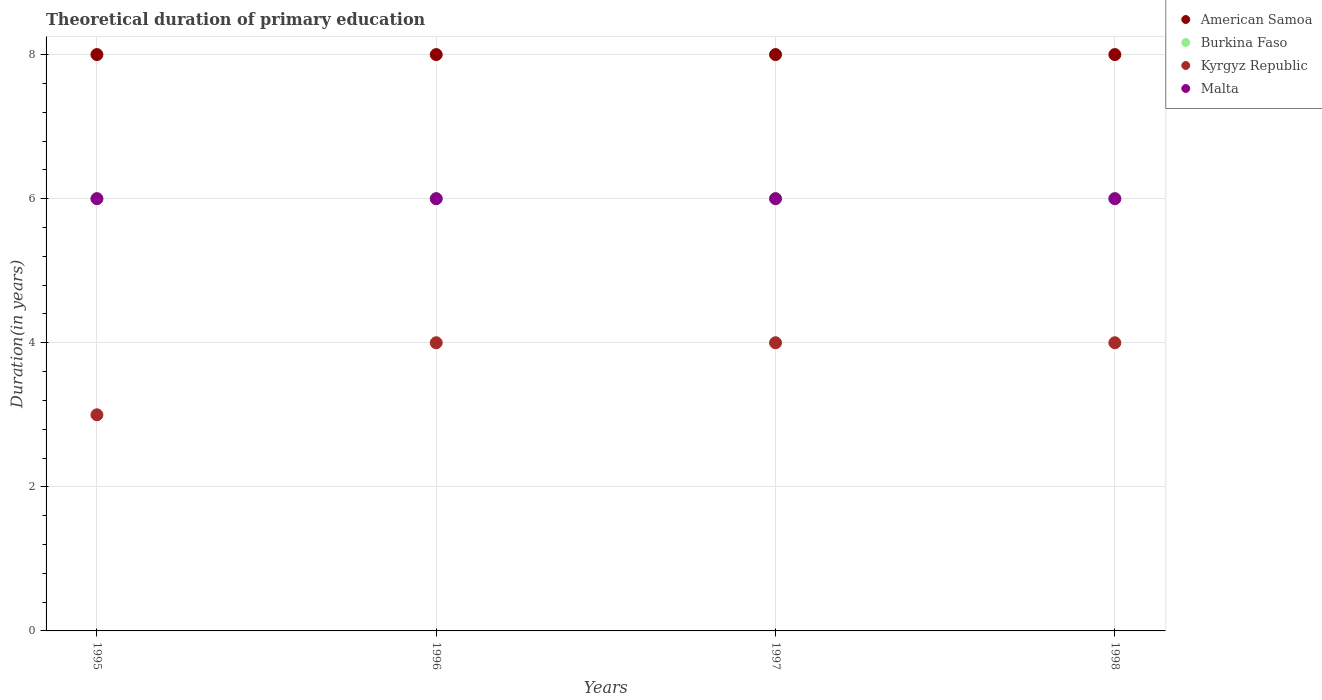How many different coloured dotlines are there?
Provide a succinct answer. 4. What is the total theoretical duration of primary education in Burkina Faso in 1998?
Your response must be concise. 6. Across all years, what is the maximum total theoretical duration of primary education in Kyrgyz Republic?
Your answer should be very brief. 4. Across all years, what is the minimum total theoretical duration of primary education in Kyrgyz Republic?
Your response must be concise. 3. In which year was the total theoretical duration of primary education in Malta maximum?
Keep it short and to the point. 1995. What is the total total theoretical duration of primary education in Burkina Faso in the graph?
Your answer should be very brief. 24. In how many years, is the total theoretical duration of primary education in Malta greater than 5.2 years?
Provide a short and direct response. 4. What is the ratio of the total theoretical duration of primary education in Kyrgyz Republic in 1996 to that in 1998?
Provide a succinct answer. 1. What is the difference between the highest and the lowest total theoretical duration of primary education in Kyrgyz Republic?
Your answer should be compact. 1. In how many years, is the total theoretical duration of primary education in American Samoa greater than the average total theoretical duration of primary education in American Samoa taken over all years?
Keep it short and to the point. 0. Does the total theoretical duration of primary education in American Samoa monotonically increase over the years?
Offer a terse response. No. How many years are there in the graph?
Your answer should be very brief. 4. Does the graph contain any zero values?
Keep it short and to the point. No. Does the graph contain grids?
Your response must be concise. Yes. Where does the legend appear in the graph?
Ensure brevity in your answer.  Top right. How many legend labels are there?
Your answer should be very brief. 4. What is the title of the graph?
Make the answer very short. Theoretical duration of primary education. Does "Somalia" appear as one of the legend labels in the graph?
Ensure brevity in your answer.  No. What is the label or title of the X-axis?
Ensure brevity in your answer.  Years. What is the label or title of the Y-axis?
Your answer should be compact. Duration(in years). What is the Duration(in years) in Kyrgyz Republic in 1995?
Give a very brief answer. 3. What is the Duration(in years) of American Samoa in 1996?
Provide a succinct answer. 8. What is the Duration(in years) of Burkina Faso in 1996?
Offer a terse response. 6. What is the Duration(in years) of Kyrgyz Republic in 1996?
Provide a short and direct response. 4. What is the Duration(in years) of American Samoa in 1997?
Offer a very short reply. 8. What is the Duration(in years) in Malta in 1997?
Offer a very short reply. 6. What is the Duration(in years) of Burkina Faso in 1998?
Offer a terse response. 6. What is the Duration(in years) of Kyrgyz Republic in 1998?
Provide a succinct answer. 4. Across all years, what is the maximum Duration(in years) in American Samoa?
Ensure brevity in your answer.  8. Across all years, what is the maximum Duration(in years) in Burkina Faso?
Make the answer very short. 6. Across all years, what is the maximum Duration(in years) in Kyrgyz Republic?
Offer a terse response. 4. What is the total Duration(in years) in American Samoa in the graph?
Ensure brevity in your answer.  32. What is the total Duration(in years) of Kyrgyz Republic in the graph?
Make the answer very short. 15. What is the difference between the Duration(in years) of Kyrgyz Republic in 1995 and that in 1996?
Give a very brief answer. -1. What is the difference between the Duration(in years) in Malta in 1995 and that in 1996?
Provide a succinct answer. 0. What is the difference between the Duration(in years) in Malta in 1995 and that in 1997?
Your answer should be very brief. 0. What is the difference between the Duration(in years) in American Samoa in 1995 and that in 1998?
Provide a short and direct response. 0. What is the difference between the Duration(in years) of Burkina Faso in 1995 and that in 1998?
Provide a succinct answer. 0. What is the difference between the Duration(in years) in Kyrgyz Republic in 1995 and that in 1998?
Your response must be concise. -1. What is the difference between the Duration(in years) in Malta in 1995 and that in 1998?
Offer a terse response. 0. What is the difference between the Duration(in years) of American Samoa in 1996 and that in 1997?
Ensure brevity in your answer.  0. What is the difference between the Duration(in years) of American Samoa in 1996 and that in 1998?
Keep it short and to the point. 0. What is the difference between the Duration(in years) in Burkina Faso in 1996 and that in 1998?
Give a very brief answer. 0. What is the difference between the Duration(in years) of Kyrgyz Republic in 1996 and that in 1998?
Keep it short and to the point. 0. What is the difference between the Duration(in years) in American Samoa in 1997 and that in 1998?
Offer a terse response. 0. What is the difference between the Duration(in years) in Burkina Faso in 1997 and that in 1998?
Provide a succinct answer. 0. What is the difference between the Duration(in years) in Burkina Faso in 1995 and the Duration(in years) in Kyrgyz Republic in 1996?
Offer a terse response. 2. What is the difference between the Duration(in years) in Kyrgyz Republic in 1995 and the Duration(in years) in Malta in 1996?
Your answer should be very brief. -3. What is the difference between the Duration(in years) of American Samoa in 1995 and the Duration(in years) of Kyrgyz Republic in 1997?
Provide a succinct answer. 4. What is the difference between the Duration(in years) of American Samoa in 1995 and the Duration(in years) of Malta in 1997?
Keep it short and to the point. 2. What is the difference between the Duration(in years) of American Samoa in 1995 and the Duration(in years) of Burkina Faso in 1998?
Offer a terse response. 2. What is the difference between the Duration(in years) in American Samoa in 1995 and the Duration(in years) in Kyrgyz Republic in 1998?
Your answer should be very brief. 4. What is the difference between the Duration(in years) of Burkina Faso in 1995 and the Duration(in years) of Malta in 1998?
Your answer should be compact. 0. What is the difference between the Duration(in years) of Kyrgyz Republic in 1995 and the Duration(in years) of Malta in 1998?
Make the answer very short. -3. What is the difference between the Duration(in years) of Burkina Faso in 1996 and the Duration(in years) of Kyrgyz Republic in 1998?
Your answer should be compact. 2. What is the difference between the Duration(in years) in American Samoa in 1997 and the Duration(in years) in Burkina Faso in 1998?
Give a very brief answer. 2. What is the difference between the Duration(in years) in American Samoa in 1997 and the Duration(in years) in Malta in 1998?
Your answer should be very brief. 2. What is the difference between the Duration(in years) in Burkina Faso in 1997 and the Duration(in years) in Malta in 1998?
Ensure brevity in your answer.  0. What is the difference between the Duration(in years) of Kyrgyz Republic in 1997 and the Duration(in years) of Malta in 1998?
Give a very brief answer. -2. What is the average Duration(in years) in Burkina Faso per year?
Offer a very short reply. 6. What is the average Duration(in years) of Kyrgyz Republic per year?
Make the answer very short. 3.75. In the year 1995, what is the difference between the Duration(in years) in American Samoa and Duration(in years) in Burkina Faso?
Offer a very short reply. 2. In the year 1995, what is the difference between the Duration(in years) of American Samoa and Duration(in years) of Kyrgyz Republic?
Your answer should be very brief. 5. In the year 1995, what is the difference between the Duration(in years) in American Samoa and Duration(in years) in Malta?
Your answer should be very brief. 2. In the year 1995, what is the difference between the Duration(in years) in Burkina Faso and Duration(in years) in Kyrgyz Republic?
Give a very brief answer. 3. In the year 1996, what is the difference between the Duration(in years) in American Samoa and Duration(in years) in Kyrgyz Republic?
Your answer should be compact. 4. In the year 1996, what is the difference between the Duration(in years) of American Samoa and Duration(in years) of Malta?
Offer a terse response. 2. In the year 1996, what is the difference between the Duration(in years) in Burkina Faso and Duration(in years) in Kyrgyz Republic?
Your answer should be compact. 2. In the year 1997, what is the difference between the Duration(in years) in American Samoa and Duration(in years) in Burkina Faso?
Provide a succinct answer. 2. In the year 1997, what is the difference between the Duration(in years) of American Samoa and Duration(in years) of Malta?
Give a very brief answer. 2. In the year 1997, what is the difference between the Duration(in years) in Burkina Faso and Duration(in years) in Kyrgyz Republic?
Offer a very short reply. 2. In the year 1997, what is the difference between the Duration(in years) of Kyrgyz Republic and Duration(in years) of Malta?
Offer a very short reply. -2. In the year 1998, what is the difference between the Duration(in years) of American Samoa and Duration(in years) of Burkina Faso?
Make the answer very short. 2. In the year 1998, what is the difference between the Duration(in years) in American Samoa and Duration(in years) in Malta?
Make the answer very short. 2. In the year 1998, what is the difference between the Duration(in years) of Kyrgyz Republic and Duration(in years) of Malta?
Make the answer very short. -2. What is the ratio of the Duration(in years) of Kyrgyz Republic in 1995 to that in 1996?
Offer a terse response. 0.75. What is the ratio of the Duration(in years) of Malta in 1995 to that in 1996?
Offer a very short reply. 1. What is the ratio of the Duration(in years) of Burkina Faso in 1995 to that in 1997?
Give a very brief answer. 1. What is the ratio of the Duration(in years) of Kyrgyz Republic in 1995 to that in 1997?
Your response must be concise. 0.75. What is the ratio of the Duration(in years) of Malta in 1995 to that in 1997?
Make the answer very short. 1. What is the ratio of the Duration(in years) in Kyrgyz Republic in 1995 to that in 1998?
Make the answer very short. 0.75. What is the ratio of the Duration(in years) in Burkina Faso in 1996 to that in 1997?
Your answer should be very brief. 1. What is the ratio of the Duration(in years) in American Samoa in 1996 to that in 1998?
Offer a very short reply. 1. What is the ratio of the Duration(in years) of Burkina Faso in 1996 to that in 1998?
Make the answer very short. 1. What is the ratio of the Duration(in years) in Malta in 1996 to that in 1998?
Your answer should be compact. 1. What is the ratio of the Duration(in years) of Burkina Faso in 1997 to that in 1998?
Offer a terse response. 1. What is the ratio of the Duration(in years) of Kyrgyz Republic in 1997 to that in 1998?
Your answer should be very brief. 1. What is the difference between the highest and the second highest Duration(in years) in American Samoa?
Provide a succinct answer. 0. What is the difference between the highest and the second highest Duration(in years) in Burkina Faso?
Offer a terse response. 0. What is the difference between the highest and the second highest Duration(in years) of Malta?
Offer a terse response. 0. What is the difference between the highest and the lowest Duration(in years) of Burkina Faso?
Make the answer very short. 0. What is the difference between the highest and the lowest Duration(in years) in Kyrgyz Republic?
Your answer should be very brief. 1. What is the difference between the highest and the lowest Duration(in years) in Malta?
Your answer should be compact. 0. 